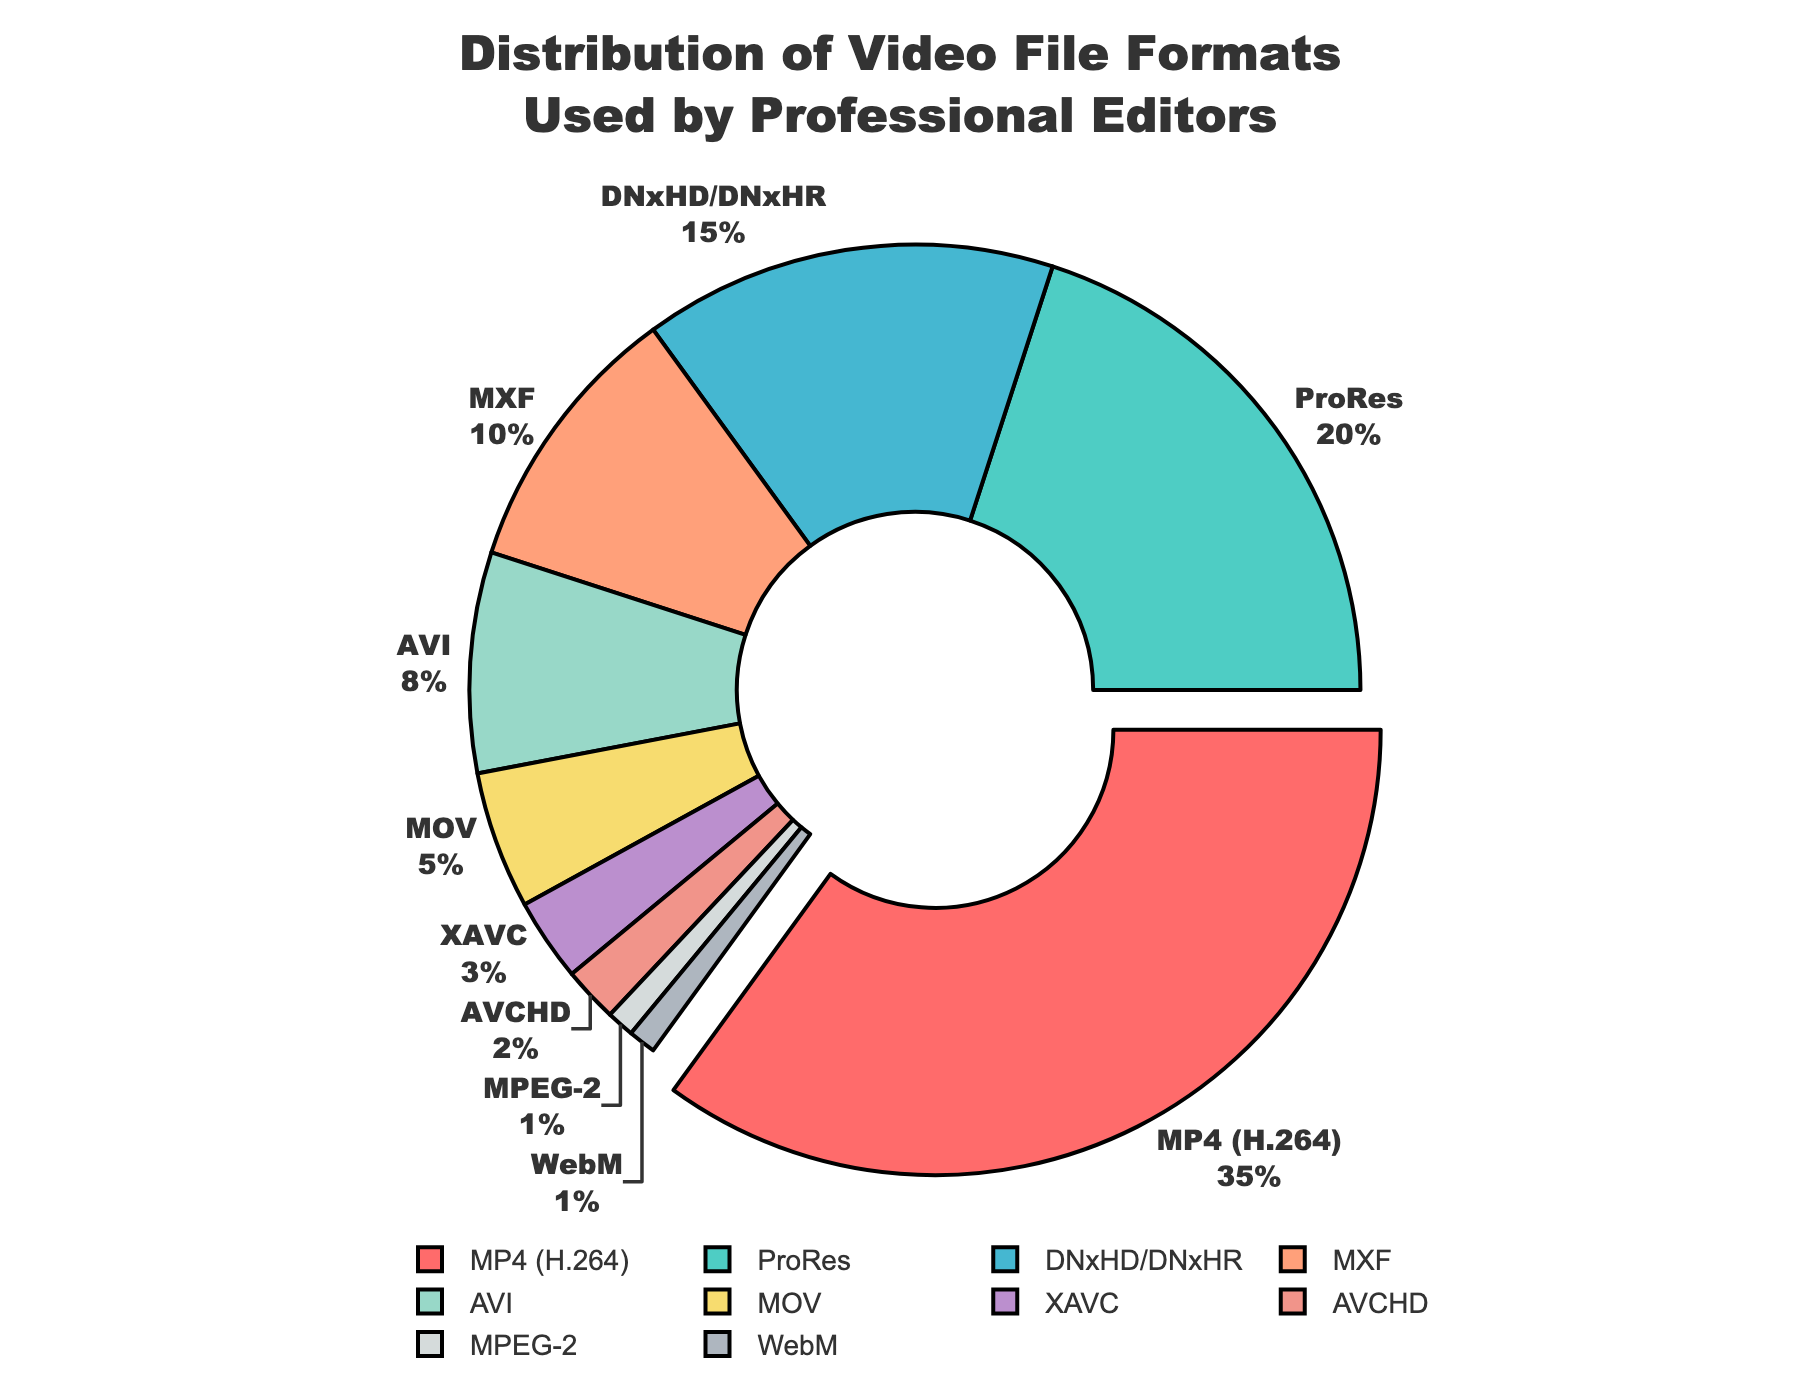What video file format is most commonly used by professional editors? The chart shows a pie slice positioned prominently with a slightly pulled-out effect, representing the highest percentage. It is labeled "MP4 (H.264)" with 35%.
Answer: MP4 (H.264) What is the combined percentage of ProRes and DNxHD/DNxHR formats? Looking at the pie chart, we identify the labels for ProRes and DNxHD/DNxHR. ProRes is 20%, and DNxHD/DNxHR is 15%. Summing them gives 20% + 15% = 35%.
Answer: 35% Which two formats have the smallest usage percentages? The pie chart has labels with percentages. WebM and MPEG-2 are both marked 1%, making them the smallest.
Answer: WebM and MPEG-2 How much larger is the percentage for MP4 (H.264) compared to MXF? The chart shows MP4 (H.264) at 35% and MXF at 10%. To find the difference: 35% - 10% = 25%.
Answer: 25% What percentage does AVI contribute to the total distribution? The pie chart label for AVI indicates 8%.
Answer: 8% If the least commonly used formats (each 1% or 2%) were removed, what would the new total percentage be for the remaining formats? The least commonly used formats are WebM (1%), MPEG-2 (1%), and AVCHD (2%). Their combined percentage is 1% + 1% + 2% = 4%. The original total is 100%, so removing these would be 100% - 4% = 96%.
Answer: 96% How do the percentages for ProRes and MOV compare? According to the pie chart, ProRes is 20% and MOV is 5%. So, ProRes is 4 times MOV.
Answer: ProRes is 4 times MOV What is the distribution difference between DNxHD/DNxHR and AVI? The chart gives 15% for DNxHD/DNxHR and 8% for AVI. The difference is 15% - 8% = 7%.
Answer: 7% What color represents DNxHD/DNxHR in the chart? The DNxHD/DNxHR segment on the pie chart is shaded in a specific color. After identifying the segment, it appears to be a light blue color.
Answer: Light Blue 